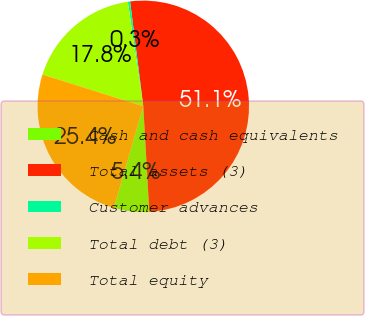<chart> <loc_0><loc_0><loc_500><loc_500><pie_chart><fcel>Cash and cash equivalents<fcel>Total assets (3)<fcel>Customer advances<fcel>Total debt (3)<fcel>Total equity<nl><fcel>5.41%<fcel>51.08%<fcel>0.34%<fcel>17.8%<fcel>25.36%<nl></chart> 